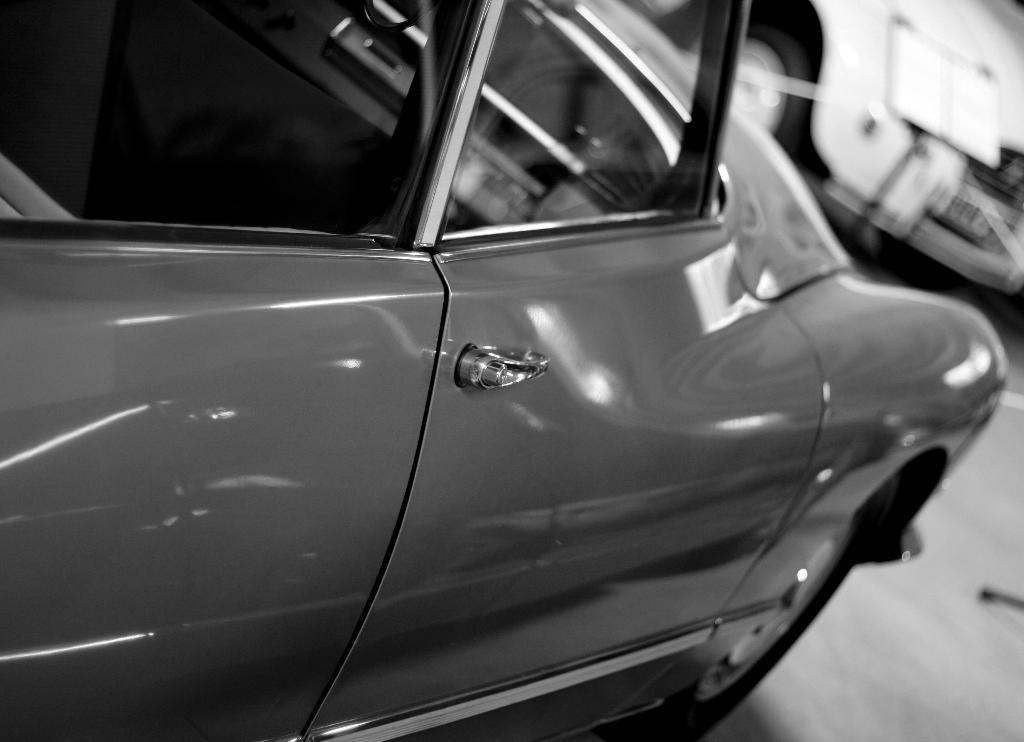What part of a car is shown in the image? There is a car door and handle in the image. How is the car door and handle depicted in the image? The car door and handle are shown from a side view. Are there any other cars visible in the image? Yes, there is another car visible in the image. What is the color of the other car? The other car is white in color. What type of punishment is being handed out to the car door in the image? There is no punishment being handed out to the car door in the image; it is simply a stationary object. 